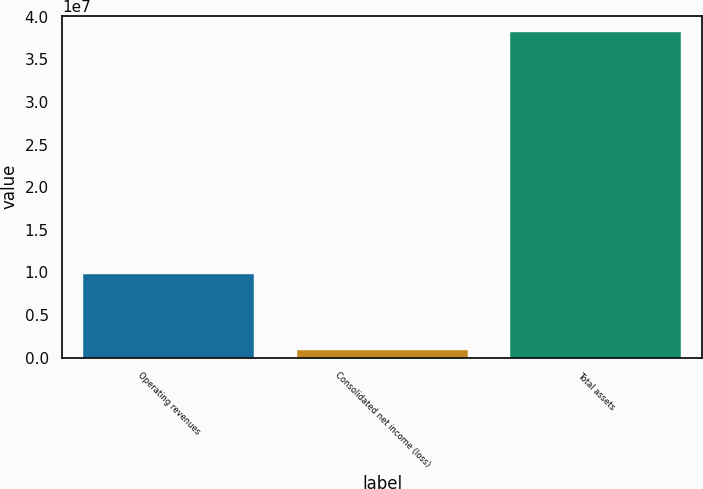Convert chart. <chart><loc_0><loc_0><loc_500><loc_500><bar_chart><fcel>Operating revenues<fcel>Consolidated net income (loss)<fcel>Total assets<nl><fcel>9.77382e+06<fcel>846496<fcel>3.81863e+07<nl></chart> 